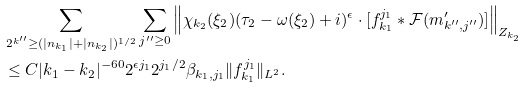<formula> <loc_0><loc_0><loc_500><loc_500>& \sum _ { 2 ^ { k ^ { \prime \prime } } \geq ( | n _ { k _ { 1 } } | + | n _ { k _ { 2 } } | ) ^ { 1 / 2 } } \sum _ { j ^ { \prime \prime } \geq 0 } \left \| \chi _ { k _ { 2 } } ( \xi _ { 2 } ) ( \tau _ { 2 } - \omega ( \xi _ { 2 } ) + i ) ^ { \epsilon } \cdot [ f _ { k _ { 1 } } ^ { j _ { 1 } } \ast \mathcal { F } ( m ^ { \prime } _ { k ^ { \prime \prime } , j ^ { \prime \prime } } ) ] \right \| _ { Z _ { k _ { 2 } } } \\ & \leq C | k _ { 1 } - k _ { 2 } | ^ { - 6 0 } 2 ^ { \epsilon j _ { 1 } } 2 ^ { j _ { 1 } / 2 } \beta _ { k _ { 1 } , j _ { 1 } } \| f _ { k _ { 1 } } ^ { j _ { 1 } } \| _ { L ^ { 2 } } .</formula> 